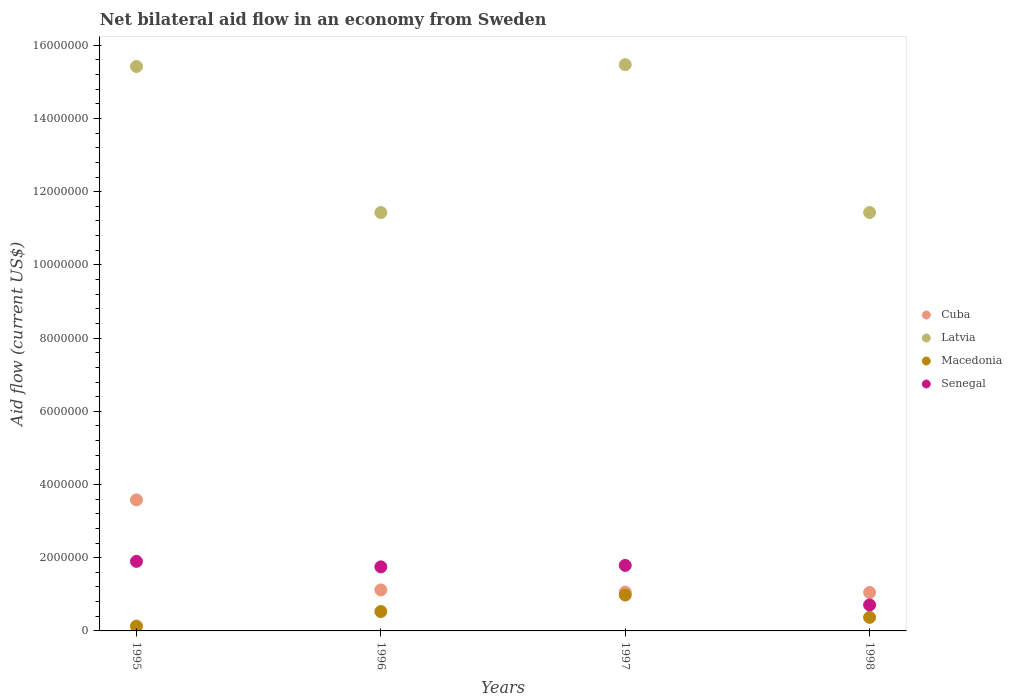Is the number of dotlines equal to the number of legend labels?
Ensure brevity in your answer.  Yes. What is the net bilateral aid flow in Cuba in 1996?
Your answer should be compact. 1.12e+06. Across all years, what is the maximum net bilateral aid flow in Macedonia?
Your response must be concise. 9.80e+05. Across all years, what is the minimum net bilateral aid flow in Cuba?
Provide a succinct answer. 1.05e+06. In which year was the net bilateral aid flow in Macedonia minimum?
Provide a succinct answer. 1995. What is the total net bilateral aid flow in Senegal in the graph?
Keep it short and to the point. 6.15e+06. What is the difference between the net bilateral aid flow in Cuba in 1995 and that in 1998?
Your answer should be very brief. 2.53e+06. What is the difference between the net bilateral aid flow in Cuba in 1998 and the net bilateral aid flow in Senegal in 1996?
Offer a very short reply. -7.00e+05. What is the average net bilateral aid flow in Senegal per year?
Your answer should be compact. 1.54e+06. In the year 1998, what is the difference between the net bilateral aid flow in Macedonia and net bilateral aid flow in Latvia?
Ensure brevity in your answer.  -1.11e+07. In how many years, is the net bilateral aid flow in Cuba greater than 10000000 US$?
Offer a terse response. 0. What is the ratio of the net bilateral aid flow in Cuba in 1996 to that in 1997?
Make the answer very short. 1.06. What is the difference between the highest and the second highest net bilateral aid flow in Cuba?
Your answer should be compact. 2.46e+06. What is the difference between the highest and the lowest net bilateral aid flow in Cuba?
Provide a succinct answer. 2.53e+06. Is the sum of the net bilateral aid flow in Latvia in 1995 and 1997 greater than the maximum net bilateral aid flow in Senegal across all years?
Make the answer very short. Yes. Is it the case that in every year, the sum of the net bilateral aid flow in Cuba and net bilateral aid flow in Macedonia  is greater than the net bilateral aid flow in Latvia?
Keep it short and to the point. No. Is the net bilateral aid flow in Latvia strictly greater than the net bilateral aid flow in Macedonia over the years?
Your response must be concise. Yes. How many dotlines are there?
Provide a succinct answer. 4. What is the difference between two consecutive major ticks on the Y-axis?
Your answer should be compact. 2.00e+06. Are the values on the major ticks of Y-axis written in scientific E-notation?
Ensure brevity in your answer.  No. Does the graph contain any zero values?
Your answer should be very brief. No. Where does the legend appear in the graph?
Offer a very short reply. Center right. How are the legend labels stacked?
Offer a very short reply. Vertical. What is the title of the graph?
Provide a short and direct response. Net bilateral aid flow in an economy from Sweden. What is the label or title of the X-axis?
Provide a succinct answer. Years. What is the label or title of the Y-axis?
Offer a terse response. Aid flow (current US$). What is the Aid flow (current US$) in Cuba in 1995?
Your response must be concise. 3.58e+06. What is the Aid flow (current US$) of Latvia in 1995?
Provide a succinct answer. 1.54e+07. What is the Aid flow (current US$) of Senegal in 1995?
Provide a succinct answer. 1.90e+06. What is the Aid flow (current US$) in Cuba in 1996?
Ensure brevity in your answer.  1.12e+06. What is the Aid flow (current US$) in Latvia in 1996?
Your answer should be compact. 1.14e+07. What is the Aid flow (current US$) of Macedonia in 1996?
Give a very brief answer. 5.30e+05. What is the Aid flow (current US$) of Senegal in 1996?
Offer a terse response. 1.75e+06. What is the Aid flow (current US$) in Cuba in 1997?
Ensure brevity in your answer.  1.06e+06. What is the Aid flow (current US$) of Latvia in 1997?
Make the answer very short. 1.55e+07. What is the Aid flow (current US$) of Macedonia in 1997?
Your response must be concise. 9.80e+05. What is the Aid flow (current US$) in Senegal in 1997?
Your answer should be compact. 1.79e+06. What is the Aid flow (current US$) in Cuba in 1998?
Offer a terse response. 1.05e+06. What is the Aid flow (current US$) in Latvia in 1998?
Give a very brief answer. 1.14e+07. What is the Aid flow (current US$) in Macedonia in 1998?
Ensure brevity in your answer.  3.70e+05. What is the Aid flow (current US$) of Senegal in 1998?
Ensure brevity in your answer.  7.10e+05. Across all years, what is the maximum Aid flow (current US$) of Cuba?
Your answer should be compact. 3.58e+06. Across all years, what is the maximum Aid flow (current US$) of Latvia?
Give a very brief answer. 1.55e+07. Across all years, what is the maximum Aid flow (current US$) in Macedonia?
Ensure brevity in your answer.  9.80e+05. Across all years, what is the maximum Aid flow (current US$) in Senegal?
Ensure brevity in your answer.  1.90e+06. Across all years, what is the minimum Aid flow (current US$) in Cuba?
Offer a terse response. 1.05e+06. Across all years, what is the minimum Aid flow (current US$) in Latvia?
Provide a succinct answer. 1.14e+07. Across all years, what is the minimum Aid flow (current US$) in Senegal?
Ensure brevity in your answer.  7.10e+05. What is the total Aid flow (current US$) in Cuba in the graph?
Make the answer very short. 6.81e+06. What is the total Aid flow (current US$) in Latvia in the graph?
Ensure brevity in your answer.  5.38e+07. What is the total Aid flow (current US$) in Macedonia in the graph?
Keep it short and to the point. 2.01e+06. What is the total Aid flow (current US$) of Senegal in the graph?
Your answer should be very brief. 6.15e+06. What is the difference between the Aid flow (current US$) in Cuba in 1995 and that in 1996?
Keep it short and to the point. 2.46e+06. What is the difference between the Aid flow (current US$) in Latvia in 1995 and that in 1996?
Provide a succinct answer. 3.99e+06. What is the difference between the Aid flow (current US$) in Macedonia in 1995 and that in 1996?
Offer a terse response. -4.00e+05. What is the difference between the Aid flow (current US$) in Cuba in 1995 and that in 1997?
Your answer should be compact. 2.52e+06. What is the difference between the Aid flow (current US$) in Latvia in 1995 and that in 1997?
Your answer should be compact. -5.00e+04. What is the difference between the Aid flow (current US$) of Macedonia in 1995 and that in 1997?
Provide a succinct answer. -8.50e+05. What is the difference between the Aid flow (current US$) of Senegal in 1995 and that in 1997?
Ensure brevity in your answer.  1.10e+05. What is the difference between the Aid flow (current US$) in Cuba in 1995 and that in 1998?
Provide a succinct answer. 2.53e+06. What is the difference between the Aid flow (current US$) of Latvia in 1995 and that in 1998?
Ensure brevity in your answer.  3.99e+06. What is the difference between the Aid flow (current US$) of Senegal in 1995 and that in 1998?
Keep it short and to the point. 1.19e+06. What is the difference between the Aid flow (current US$) in Cuba in 1996 and that in 1997?
Your response must be concise. 6.00e+04. What is the difference between the Aid flow (current US$) in Latvia in 1996 and that in 1997?
Offer a very short reply. -4.04e+06. What is the difference between the Aid flow (current US$) in Macedonia in 1996 and that in 1997?
Keep it short and to the point. -4.50e+05. What is the difference between the Aid flow (current US$) in Senegal in 1996 and that in 1997?
Your response must be concise. -4.00e+04. What is the difference between the Aid flow (current US$) of Latvia in 1996 and that in 1998?
Your answer should be very brief. 0. What is the difference between the Aid flow (current US$) in Senegal in 1996 and that in 1998?
Give a very brief answer. 1.04e+06. What is the difference between the Aid flow (current US$) of Cuba in 1997 and that in 1998?
Provide a short and direct response. 10000. What is the difference between the Aid flow (current US$) in Latvia in 1997 and that in 1998?
Provide a short and direct response. 4.04e+06. What is the difference between the Aid flow (current US$) of Senegal in 1997 and that in 1998?
Make the answer very short. 1.08e+06. What is the difference between the Aid flow (current US$) of Cuba in 1995 and the Aid flow (current US$) of Latvia in 1996?
Your answer should be very brief. -7.85e+06. What is the difference between the Aid flow (current US$) in Cuba in 1995 and the Aid flow (current US$) in Macedonia in 1996?
Your answer should be very brief. 3.05e+06. What is the difference between the Aid flow (current US$) of Cuba in 1995 and the Aid flow (current US$) of Senegal in 1996?
Keep it short and to the point. 1.83e+06. What is the difference between the Aid flow (current US$) in Latvia in 1995 and the Aid flow (current US$) in Macedonia in 1996?
Your answer should be very brief. 1.49e+07. What is the difference between the Aid flow (current US$) of Latvia in 1995 and the Aid flow (current US$) of Senegal in 1996?
Your answer should be very brief. 1.37e+07. What is the difference between the Aid flow (current US$) in Macedonia in 1995 and the Aid flow (current US$) in Senegal in 1996?
Keep it short and to the point. -1.62e+06. What is the difference between the Aid flow (current US$) of Cuba in 1995 and the Aid flow (current US$) of Latvia in 1997?
Provide a succinct answer. -1.19e+07. What is the difference between the Aid flow (current US$) of Cuba in 1995 and the Aid flow (current US$) of Macedonia in 1997?
Your answer should be compact. 2.60e+06. What is the difference between the Aid flow (current US$) in Cuba in 1995 and the Aid flow (current US$) in Senegal in 1997?
Your answer should be compact. 1.79e+06. What is the difference between the Aid flow (current US$) in Latvia in 1995 and the Aid flow (current US$) in Macedonia in 1997?
Make the answer very short. 1.44e+07. What is the difference between the Aid flow (current US$) in Latvia in 1995 and the Aid flow (current US$) in Senegal in 1997?
Give a very brief answer. 1.36e+07. What is the difference between the Aid flow (current US$) of Macedonia in 1995 and the Aid flow (current US$) of Senegal in 1997?
Provide a succinct answer. -1.66e+06. What is the difference between the Aid flow (current US$) of Cuba in 1995 and the Aid flow (current US$) of Latvia in 1998?
Ensure brevity in your answer.  -7.85e+06. What is the difference between the Aid flow (current US$) of Cuba in 1995 and the Aid flow (current US$) of Macedonia in 1998?
Give a very brief answer. 3.21e+06. What is the difference between the Aid flow (current US$) in Cuba in 1995 and the Aid flow (current US$) in Senegal in 1998?
Offer a very short reply. 2.87e+06. What is the difference between the Aid flow (current US$) in Latvia in 1995 and the Aid flow (current US$) in Macedonia in 1998?
Your answer should be very brief. 1.50e+07. What is the difference between the Aid flow (current US$) of Latvia in 1995 and the Aid flow (current US$) of Senegal in 1998?
Provide a short and direct response. 1.47e+07. What is the difference between the Aid flow (current US$) of Macedonia in 1995 and the Aid flow (current US$) of Senegal in 1998?
Your answer should be compact. -5.80e+05. What is the difference between the Aid flow (current US$) of Cuba in 1996 and the Aid flow (current US$) of Latvia in 1997?
Keep it short and to the point. -1.44e+07. What is the difference between the Aid flow (current US$) in Cuba in 1996 and the Aid flow (current US$) in Macedonia in 1997?
Give a very brief answer. 1.40e+05. What is the difference between the Aid flow (current US$) of Cuba in 1996 and the Aid flow (current US$) of Senegal in 1997?
Ensure brevity in your answer.  -6.70e+05. What is the difference between the Aid flow (current US$) in Latvia in 1996 and the Aid flow (current US$) in Macedonia in 1997?
Offer a very short reply. 1.04e+07. What is the difference between the Aid flow (current US$) in Latvia in 1996 and the Aid flow (current US$) in Senegal in 1997?
Ensure brevity in your answer.  9.64e+06. What is the difference between the Aid flow (current US$) in Macedonia in 1996 and the Aid flow (current US$) in Senegal in 1997?
Give a very brief answer. -1.26e+06. What is the difference between the Aid flow (current US$) in Cuba in 1996 and the Aid flow (current US$) in Latvia in 1998?
Make the answer very short. -1.03e+07. What is the difference between the Aid flow (current US$) of Cuba in 1996 and the Aid flow (current US$) of Macedonia in 1998?
Provide a succinct answer. 7.50e+05. What is the difference between the Aid flow (current US$) of Cuba in 1996 and the Aid flow (current US$) of Senegal in 1998?
Provide a succinct answer. 4.10e+05. What is the difference between the Aid flow (current US$) in Latvia in 1996 and the Aid flow (current US$) in Macedonia in 1998?
Provide a short and direct response. 1.11e+07. What is the difference between the Aid flow (current US$) in Latvia in 1996 and the Aid flow (current US$) in Senegal in 1998?
Your answer should be very brief. 1.07e+07. What is the difference between the Aid flow (current US$) of Macedonia in 1996 and the Aid flow (current US$) of Senegal in 1998?
Ensure brevity in your answer.  -1.80e+05. What is the difference between the Aid flow (current US$) of Cuba in 1997 and the Aid flow (current US$) of Latvia in 1998?
Make the answer very short. -1.04e+07. What is the difference between the Aid flow (current US$) in Cuba in 1997 and the Aid flow (current US$) in Macedonia in 1998?
Offer a very short reply. 6.90e+05. What is the difference between the Aid flow (current US$) in Cuba in 1997 and the Aid flow (current US$) in Senegal in 1998?
Provide a short and direct response. 3.50e+05. What is the difference between the Aid flow (current US$) in Latvia in 1997 and the Aid flow (current US$) in Macedonia in 1998?
Ensure brevity in your answer.  1.51e+07. What is the difference between the Aid flow (current US$) in Latvia in 1997 and the Aid flow (current US$) in Senegal in 1998?
Provide a succinct answer. 1.48e+07. What is the average Aid flow (current US$) in Cuba per year?
Keep it short and to the point. 1.70e+06. What is the average Aid flow (current US$) in Latvia per year?
Keep it short and to the point. 1.34e+07. What is the average Aid flow (current US$) of Macedonia per year?
Make the answer very short. 5.02e+05. What is the average Aid flow (current US$) in Senegal per year?
Make the answer very short. 1.54e+06. In the year 1995, what is the difference between the Aid flow (current US$) of Cuba and Aid flow (current US$) of Latvia?
Your answer should be very brief. -1.18e+07. In the year 1995, what is the difference between the Aid flow (current US$) in Cuba and Aid flow (current US$) in Macedonia?
Ensure brevity in your answer.  3.45e+06. In the year 1995, what is the difference between the Aid flow (current US$) in Cuba and Aid flow (current US$) in Senegal?
Offer a terse response. 1.68e+06. In the year 1995, what is the difference between the Aid flow (current US$) of Latvia and Aid flow (current US$) of Macedonia?
Your answer should be very brief. 1.53e+07. In the year 1995, what is the difference between the Aid flow (current US$) in Latvia and Aid flow (current US$) in Senegal?
Provide a succinct answer. 1.35e+07. In the year 1995, what is the difference between the Aid flow (current US$) in Macedonia and Aid flow (current US$) in Senegal?
Give a very brief answer. -1.77e+06. In the year 1996, what is the difference between the Aid flow (current US$) in Cuba and Aid flow (current US$) in Latvia?
Give a very brief answer. -1.03e+07. In the year 1996, what is the difference between the Aid flow (current US$) of Cuba and Aid flow (current US$) of Macedonia?
Offer a terse response. 5.90e+05. In the year 1996, what is the difference between the Aid flow (current US$) of Cuba and Aid flow (current US$) of Senegal?
Provide a short and direct response. -6.30e+05. In the year 1996, what is the difference between the Aid flow (current US$) of Latvia and Aid flow (current US$) of Macedonia?
Your answer should be very brief. 1.09e+07. In the year 1996, what is the difference between the Aid flow (current US$) of Latvia and Aid flow (current US$) of Senegal?
Keep it short and to the point. 9.68e+06. In the year 1996, what is the difference between the Aid flow (current US$) in Macedonia and Aid flow (current US$) in Senegal?
Offer a terse response. -1.22e+06. In the year 1997, what is the difference between the Aid flow (current US$) of Cuba and Aid flow (current US$) of Latvia?
Your answer should be compact. -1.44e+07. In the year 1997, what is the difference between the Aid flow (current US$) in Cuba and Aid flow (current US$) in Senegal?
Provide a short and direct response. -7.30e+05. In the year 1997, what is the difference between the Aid flow (current US$) of Latvia and Aid flow (current US$) of Macedonia?
Provide a succinct answer. 1.45e+07. In the year 1997, what is the difference between the Aid flow (current US$) of Latvia and Aid flow (current US$) of Senegal?
Your response must be concise. 1.37e+07. In the year 1997, what is the difference between the Aid flow (current US$) of Macedonia and Aid flow (current US$) of Senegal?
Keep it short and to the point. -8.10e+05. In the year 1998, what is the difference between the Aid flow (current US$) of Cuba and Aid flow (current US$) of Latvia?
Keep it short and to the point. -1.04e+07. In the year 1998, what is the difference between the Aid flow (current US$) in Cuba and Aid flow (current US$) in Macedonia?
Your answer should be compact. 6.80e+05. In the year 1998, what is the difference between the Aid flow (current US$) of Latvia and Aid flow (current US$) of Macedonia?
Keep it short and to the point. 1.11e+07. In the year 1998, what is the difference between the Aid flow (current US$) of Latvia and Aid flow (current US$) of Senegal?
Your answer should be compact. 1.07e+07. What is the ratio of the Aid flow (current US$) in Cuba in 1995 to that in 1996?
Your answer should be very brief. 3.2. What is the ratio of the Aid flow (current US$) of Latvia in 1995 to that in 1996?
Keep it short and to the point. 1.35. What is the ratio of the Aid flow (current US$) in Macedonia in 1995 to that in 1996?
Make the answer very short. 0.25. What is the ratio of the Aid flow (current US$) of Senegal in 1995 to that in 1996?
Ensure brevity in your answer.  1.09. What is the ratio of the Aid flow (current US$) of Cuba in 1995 to that in 1997?
Keep it short and to the point. 3.38. What is the ratio of the Aid flow (current US$) of Macedonia in 1995 to that in 1997?
Make the answer very short. 0.13. What is the ratio of the Aid flow (current US$) of Senegal in 1995 to that in 1997?
Give a very brief answer. 1.06. What is the ratio of the Aid flow (current US$) in Cuba in 1995 to that in 1998?
Keep it short and to the point. 3.41. What is the ratio of the Aid flow (current US$) in Latvia in 1995 to that in 1998?
Your answer should be very brief. 1.35. What is the ratio of the Aid flow (current US$) of Macedonia in 1995 to that in 1998?
Your answer should be very brief. 0.35. What is the ratio of the Aid flow (current US$) of Senegal in 1995 to that in 1998?
Make the answer very short. 2.68. What is the ratio of the Aid flow (current US$) of Cuba in 1996 to that in 1997?
Your response must be concise. 1.06. What is the ratio of the Aid flow (current US$) of Latvia in 1996 to that in 1997?
Your answer should be very brief. 0.74. What is the ratio of the Aid flow (current US$) of Macedonia in 1996 to that in 1997?
Provide a succinct answer. 0.54. What is the ratio of the Aid flow (current US$) of Senegal in 1996 to that in 1997?
Provide a short and direct response. 0.98. What is the ratio of the Aid flow (current US$) in Cuba in 1996 to that in 1998?
Give a very brief answer. 1.07. What is the ratio of the Aid flow (current US$) of Macedonia in 1996 to that in 1998?
Ensure brevity in your answer.  1.43. What is the ratio of the Aid flow (current US$) of Senegal in 1996 to that in 1998?
Give a very brief answer. 2.46. What is the ratio of the Aid flow (current US$) of Cuba in 1997 to that in 1998?
Make the answer very short. 1.01. What is the ratio of the Aid flow (current US$) of Latvia in 1997 to that in 1998?
Your answer should be very brief. 1.35. What is the ratio of the Aid flow (current US$) in Macedonia in 1997 to that in 1998?
Keep it short and to the point. 2.65. What is the ratio of the Aid flow (current US$) in Senegal in 1997 to that in 1998?
Offer a very short reply. 2.52. What is the difference between the highest and the second highest Aid flow (current US$) in Cuba?
Provide a succinct answer. 2.46e+06. What is the difference between the highest and the second highest Aid flow (current US$) in Latvia?
Provide a succinct answer. 5.00e+04. What is the difference between the highest and the second highest Aid flow (current US$) of Macedonia?
Make the answer very short. 4.50e+05. What is the difference between the highest and the second highest Aid flow (current US$) of Senegal?
Your response must be concise. 1.10e+05. What is the difference between the highest and the lowest Aid flow (current US$) in Cuba?
Provide a succinct answer. 2.53e+06. What is the difference between the highest and the lowest Aid flow (current US$) of Latvia?
Your answer should be compact. 4.04e+06. What is the difference between the highest and the lowest Aid flow (current US$) in Macedonia?
Keep it short and to the point. 8.50e+05. What is the difference between the highest and the lowest Aid flow (current US$) of Senegal?
Your response must be concise. 1.19e+06. 